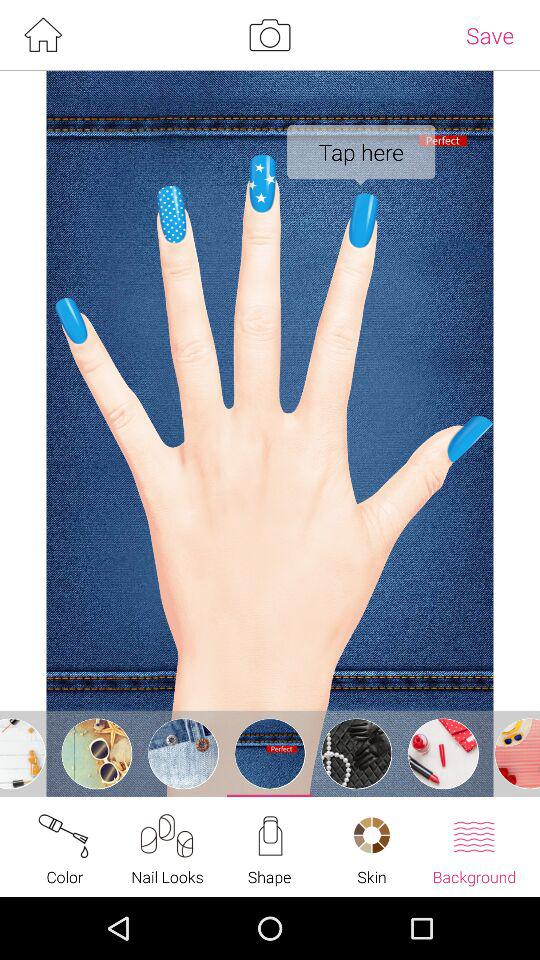Which is the selected tab? The selected tab is "Background". 